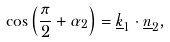<formula> <loc_0><loc_0><loc_500><loc_500>\cos \left ( \frac { \pi } { 2 } + \alpha _ { 2 } \right ) = \underline { k } _ { 1 } \cdot \underline { n } _ { 2 } ,</formula> 